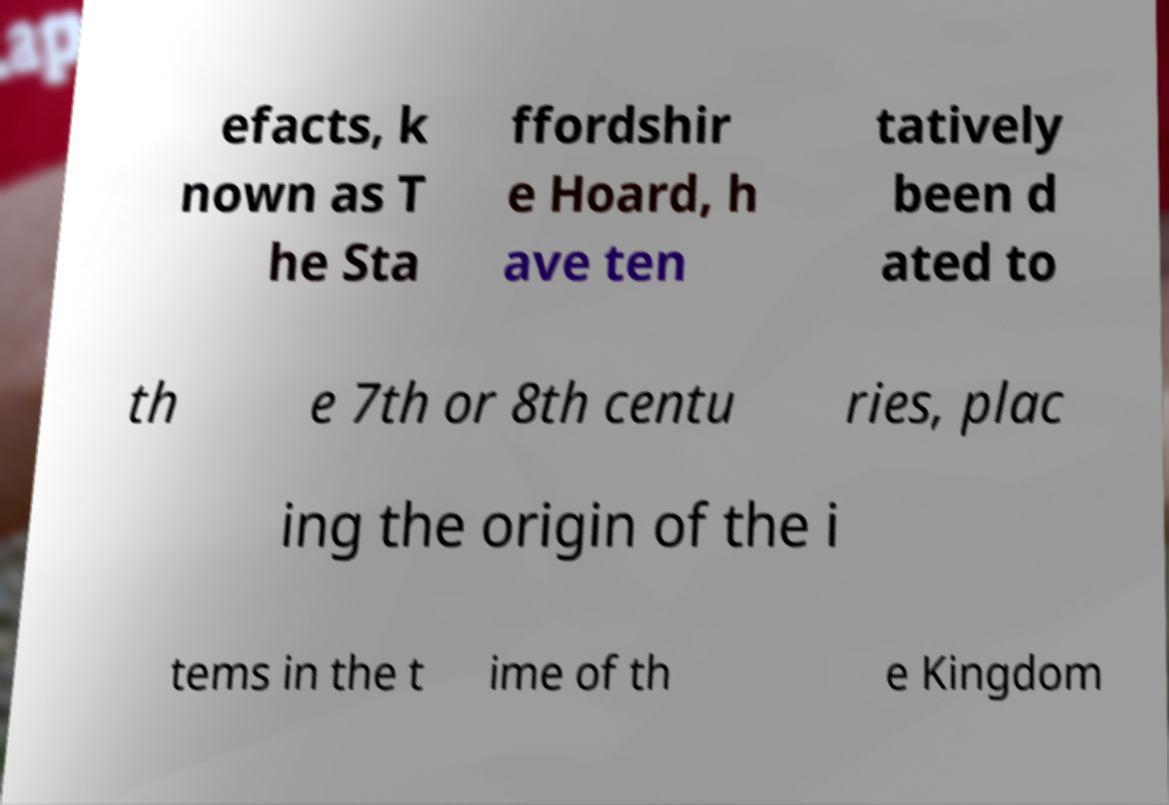Could you assist in decoding the text presented in this image and type it out clearly? efacts, k nown as T he Sta ffordshir e Hoard, h ave ten tatively been d ated to th e 7th or 8th centu ries, plac ing the origin of the i tems in the t ime of th e Kingdom 